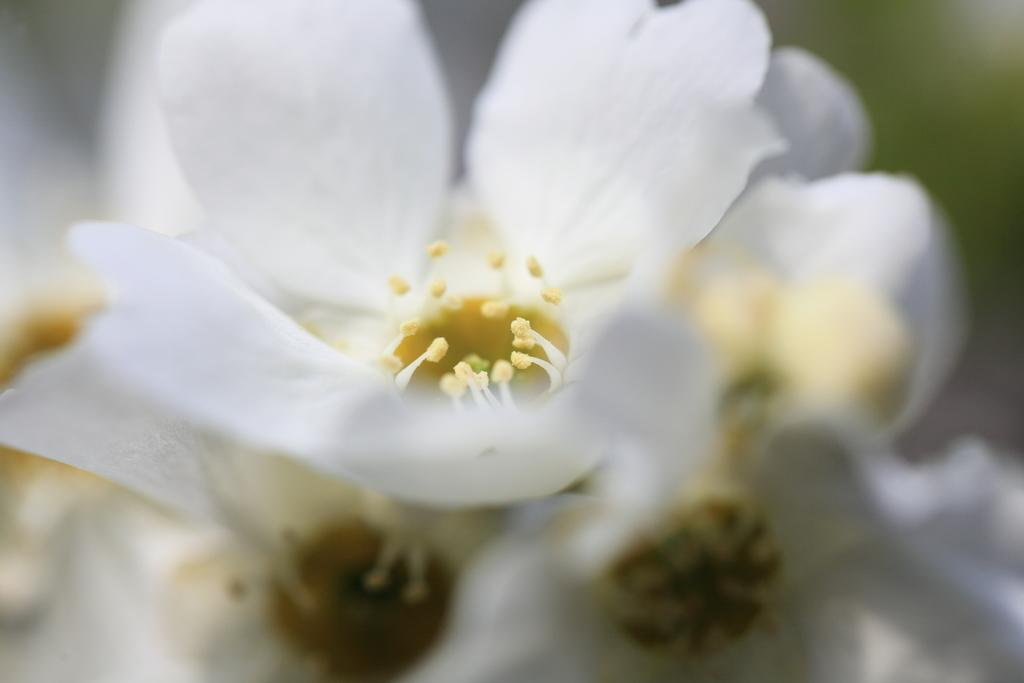What type of flowers are present in the image? There are white flowers in the image. Can you describe the background of the image? The background of the image is blurry. How many oranges are hanging from the pocket in the image? There are no oranges or pockets present in the image. What type of current can be seen flowing through the image? There is no current visible in the image; it features white flowers and a blurry background. 